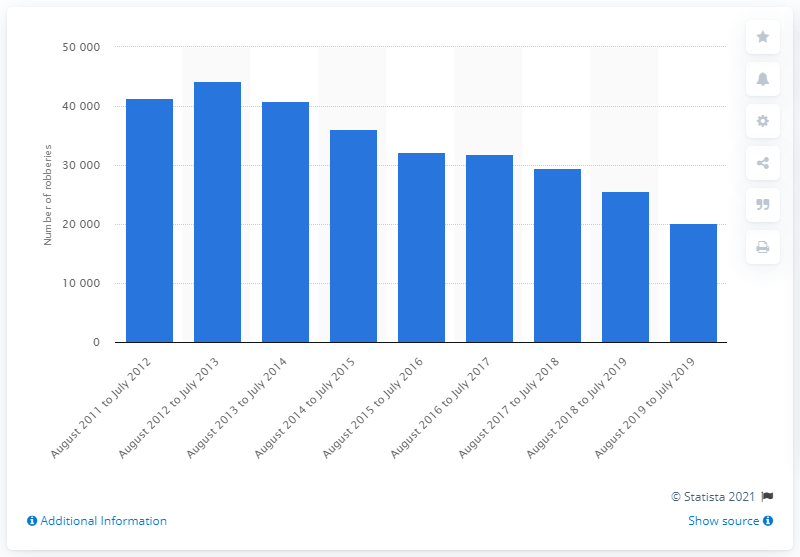Highlight a few significant elements in this photo. There were a total of 44,228 robberies between 2012 and 2013. There were 20,193 robberies in Italy between August 2019 and July 2020. 